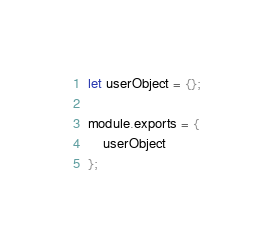Convert code to text. <code><loc_0><loc_0><loc_500><loc_500><_JavaScript_>let userObject = {};

module.exports = {
    userObject
};</code> 